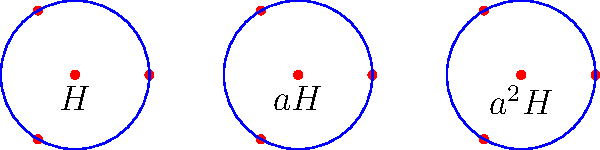Consider the dihedral group $D_4$ of order 8, and let $H = \{e, r^2\}$ be a subgroup of $D_4$, where $e$ is the identity element and $r$ is a rotation by 90°. The coset diagram for $D_4/H$ is shown above. Determine the order of the element $aH$ in the quotient group $D_4/H$, where $a$ represents a rotation by 90°. Let's approach this step-by-step:

1) First, recall that in the quotient group $D_4/H$, the elements are the cosets of $H$ in $D_4$.

2) From the coset diagram, we can see that there are three distinct cosets: $H$, $aH$, and $a^2H$.

3) To find the order of $aH$ in $D_4/H$, we need to determine how many times we need to apply $aH$ to itself to get back to the identity element (which is $H$ in the quotient group).

4) Let's compute the powers of $aH$:
   $(aH)^1 = aH$
   $(aH)^2 = a^2H$
   $(aH)^3 = a^3H = H$ (because $a^4 = e$ in $D_4$, so $a^3H = a^{-1}H = H$)

5) We see that $(aH)^3 = H$, which means that applying $aH$ three times brings us back to the identity element in the quotient group.

6) Therefore, the order of $aH$ in $D_4/H$ is 3.

This result also aligns with the fact that $|D_4/H| = |D_4|/|H| = 8/2 = 4$, and the only possible orders for elements in a group of order 4 are 1, 2, and 4.
Answer: 3 